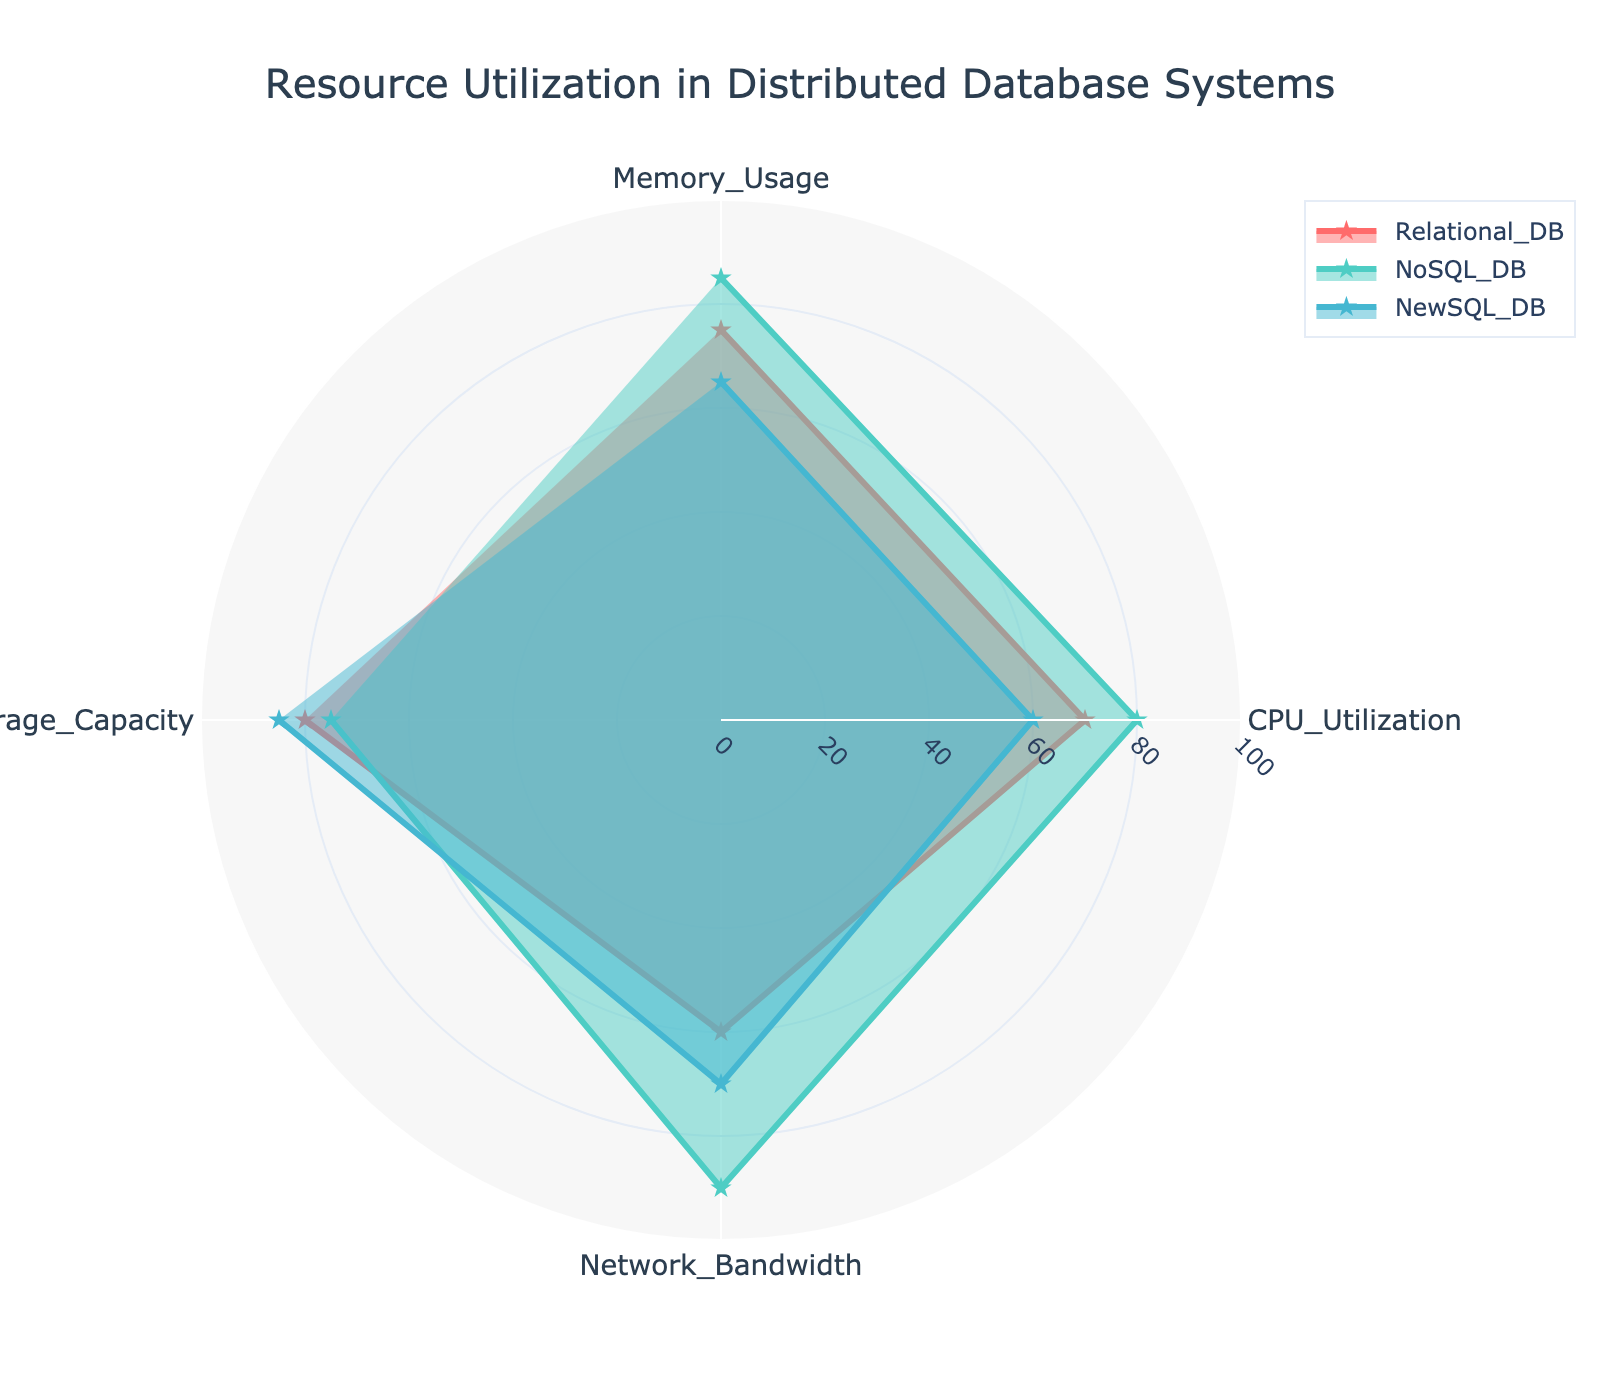What is the title of the radar chart? The title of the radar chart is located at the top of the figure and provides a summary of what the chart is about.
Answer: Resource Utilization in Distributed Database Systems Which database type shows the highest memory usage? By examining the radial points on the "Memory Usage" axis, we can see which database type extends furthest.
Answer: NoSQL_DB What is the difference in CPU utilization between Relational_DB and NewSQL_DB? The values for CPU Utilization are 70 for Relational_DB and 60 for NewSQL_DB. Subtract the latter from the former: 70 - 60.
Answer: 10 Compare the storage capacity between NoSQL_DB and NewSQL_DB. Which one is higher? Look at the values on the "Storage Capacity" axis. NoSQL_DB has a value of 75, while NewSQL_DB has a value of 85.
Answer: NewSQL_DB Does any database type meet or exceed 90% in any resource utilization category? Check all the values plotted on each axis for each database type. The maximum value plotted is 90 for NoSQL_DB in "Network Bandwidth".
Answer: Yes What is the average memory usage across the three database types? Add the memory usage values for all three databases and divide by three: (75 + 85 + 65) / 3.
Answer: 75 Which database type shows the lowest network bandwidth? By looking at the radial points on the "Network Bandwidth" axis, we can see which database type has the lowest value.
Answer: Relational_DB How does the CPU utilization of NoSQL_DB compare to its network bandwidth utilization? Look at the values for NoSQL_DB in both the "CPU Utilization" and "Network Bandwidth" categories. CPU Utilization is 80, while Network Bandwidth is 90.
Answer: Network Bandwidth is higher What is the range of storage capacities across the three database types? The range is calculated by subtracting the smallest value from the largest value: 85 (NewSQL_DB) - 75 (NoSQL_DB).
Answer: 10 Which category shows the most variance between the database types? Compare the values across each category (Memory Usage, CPU Utilization, Network Bandwidth, Storage Capacity). Network Bandwidth varies from 60 to 90, a range of 30, which is the highest.
Answer: Network Bandwidth 